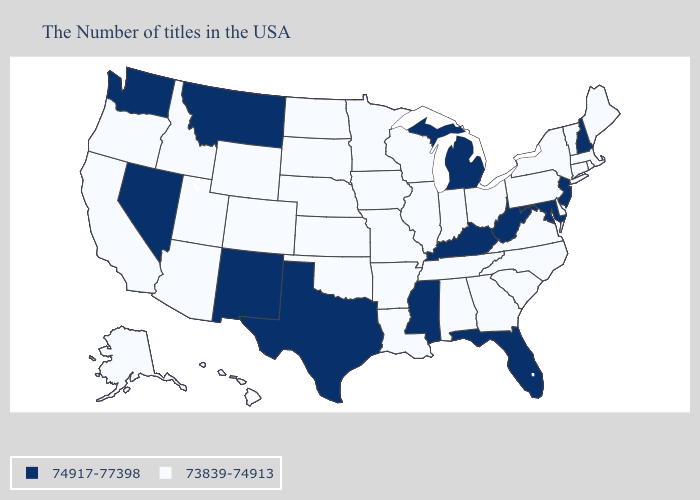What is the value of Wyoming?
Write a very short answer. 73839-74913. What is the lowest value in the South?
Quick response, please. 73839-74913. What is the highest value in states that border Tennessee?
Be succinct. 74917-77398. Which states have the lowest value in the MidWest?
Answer briefly. Ohio, Indiana, Wisconsin, Illinois, Missouri, Minnesota, Iowa, Kansas, Nebraska, South Dakota, North Dakota. What is the value of North Dakota?
Short answer required. 73839-74913. Name the states that have a value in the range 73839-74913?
Write a very short answer. Maine, Massachusetts, Rhode Island, Vermont, Connecticut, New York, Delaware, Pennsylvania, Virginia, North Carolina, South Carolina, Ohio, Georgia, Indiana, Alabama, Tennessee, Wisconsin, Illinois, Louisiana, Missouri, Arkansas, Minnesota, Iowa, Kansas, Nebraska, Oklahoma, South Dakota, North Dakota, Wyoming, Colorado, Utah, Arizona, Idaho, California, Oregon, Alaska, Hawaii. What is the lowest value in the USA?
Be succinct. 73839-74913. What is the value of Idaho?
Quick response, please. 73839-74913. Does Oregon have the highest value in the West?
Quick response, please. No. Does Nebraska have the same value as Arizona?
Concise answer only. Yes. Name the states that have a value in the range 73839-74913?
Short answer required. Maine, Massachusetts, Rhode Island, Vermont, Connecticut, New York, Delaware, Pennsylvania, Virginia, North Carolina, South Carolina, Ohio, Georgia, Indiana, Alabama, Tennessee, Wisconsin, Illinois, Louisiana, Missouri, Arkansas, Minnesota, Iowa, Kansas, Nebraska, Oklahoma, South Dakota, North Dakota, Wyoming, Colorado, Utah, Arizona, Idaho, California, Oregon, Alaska, Hawaii. Does Maine have the lowest value in the Northeast?
Write a very short answer. Yes. Which states hav the highest value in the Northeast?
Be succinct. New Hampshire, New Jersey. Does the first symbol in the legend represent the smallest category?
Write a very short answer. No. 